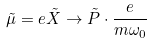Convert formula to latex. <formula><loc_0><loc_0><loc_500><loc_500>\tilde { \mu } = e \tilde { X } \rightarrow \tilde { P } \cdot \frac { e } { m \omega _ { 0 } }</formula> 